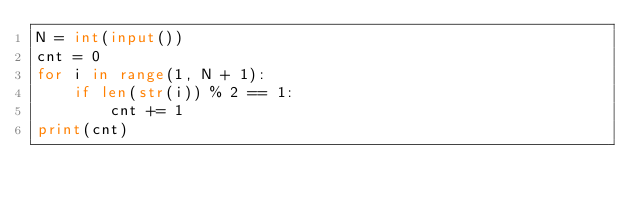Convert code to text. <code><loc_0><loc_0><loc_500><loc_500><_Python_>N = int(input())
cnt = 0
for i in range(1, N + 1):
    if len(str(i)) % 2 == 1:
        cnt += 1
print(cnt)</code> 